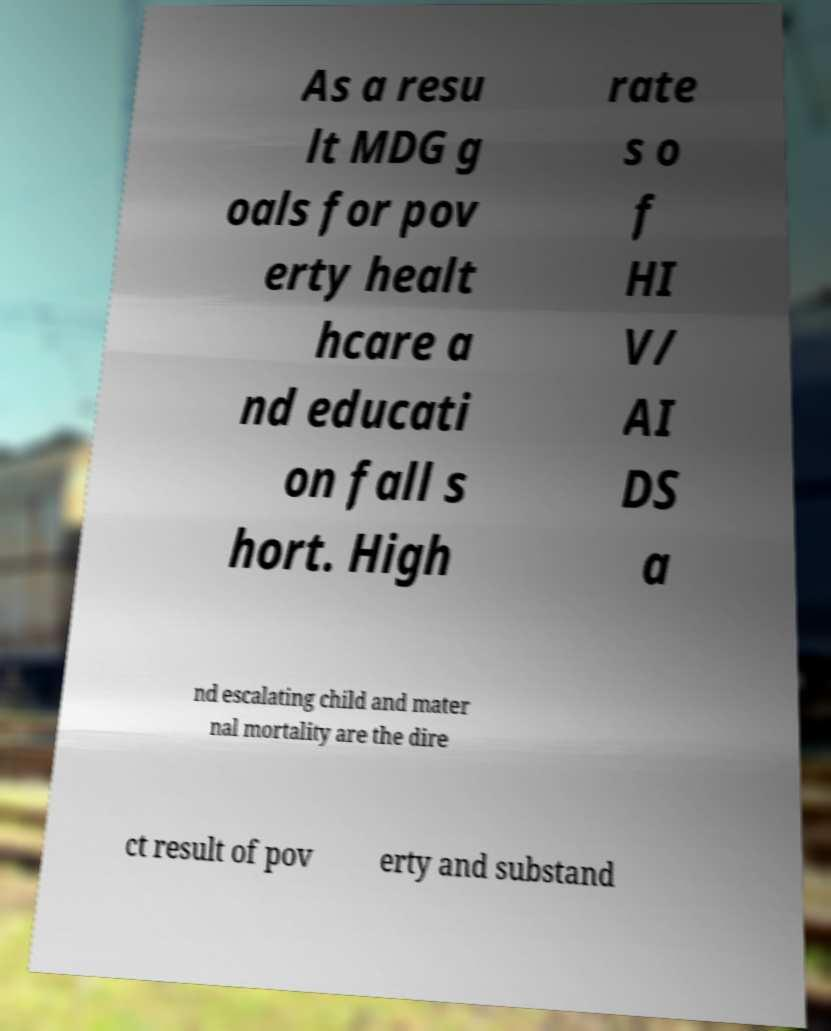Please identify and transcribe the text found in this image. As a resu lt MDG g oals for pov erty healt hcare a nd educati on fall s hort. High rate s o f HI V/ AI DS a nd escalating child and mater nal mortality are the dire ct result of pov erty and substand 